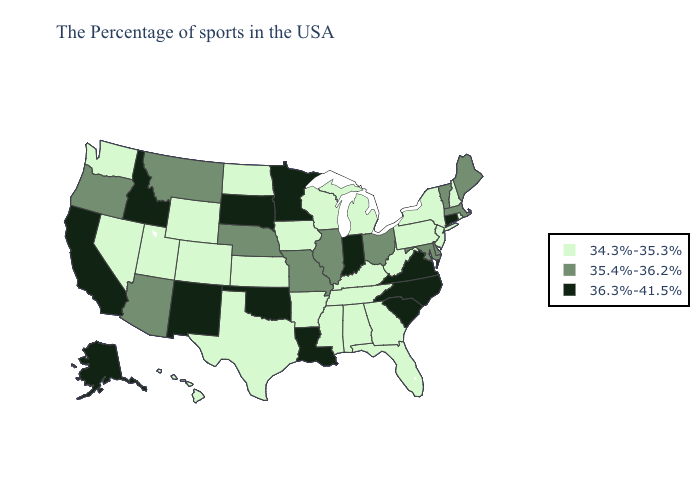Among the states that border Michigan , which have the lowest value?
Keep it brief. Wisconsin. What is the value of North Carolina?
Quick response, please. 36.3%-41.5%. Does West Virginia have the highest value in the South?
Quick response, please. No. Does Nevada have the same value as Illinois?
Answer briefly. No. Name the states that have a value in the range 35.4%-36.2%?
Give a very brief answer. Maine, Massachusetts, Vermont, Delaware, Maryland, Ohio, Illinois, Missouri, Nebraska, Montana, Arizona, Oregon. Does Oklahoma have the highest value in the South?
Write a very short answer. Yes. What is the value of California?
Be succinct. 36.3%-41.5%. What is the value of Louisiana?
Keep it brief. 36.3%-41.5%. What is the value of Idaho?
Be succinct. 36.3%-41.5%. What is the value of West Virginia?
Quick response, please. 34.3%-35.3%. Does Connecticut have the highest value in the Northeast?
Keep it brief. Yes. Does California have the lowest value in the West?
Short answer required. No. Which states have the highest value in the USA?
Be succinct. Connecticut, Virginia, North Carolina, South Carolina, Indiana, Louisiana, Minnesota, Oklahoma, South Dakota, New Mexico, Idaho, California, Alaska. Does the map have missing data?
Write a very short answer. No. 